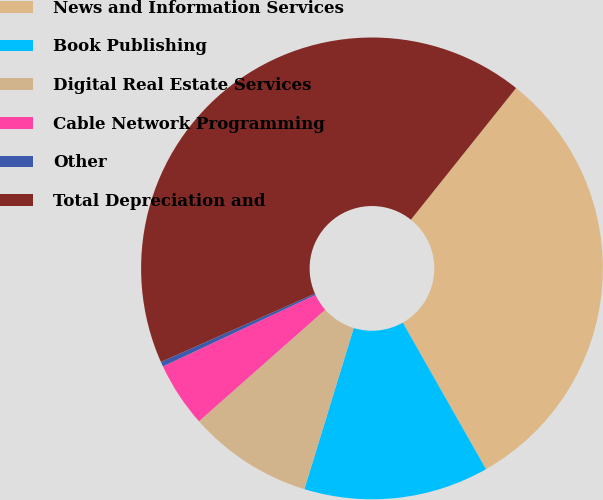Convert chart to OTSL. <chart><loc_0><loc_0><loc_500><loc_500><pie_chart><fcel>News and Information Services<fcel>Book Publishing<fcel>Digital Real Estate Services<fcel>Cable Network Programming<fcel>Other<fcel>Total Depreciation and<nl><fcel>31.05%<fcel>12.95%<fcel>8.75%<fcel>4.54%<fcel>0.34%<fcel>42.37%<nl></chart> 